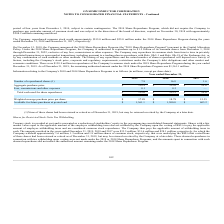According to On Semiconductor's financial document, When was "Capital Allocation Policy" announced? According to the financial document, December 1, 2014. The relevant text states: "period of four years from December 1, 2014, subject to certain contingencies. The 2014 Share Repurchase Program, which did not require the Com..." Also, How is "free cash flow" defined for the the purposes of the Capital Allocation Policy? Based on the financial document, the answer is net cash provided by operating activities less purchases of property, plant and equipment.. Also, What is the aggregate purchase price in 2019? According to the financial document, $138.9 (in millions). The relevant text states: "d other market and economic conditions. There were $138.9 million in repurchases of the Company's common stock under the 2018 Share Repurchase Program during..." Also, can you calculate: What is the change in Number of repurchased shares from December 31, 2018 to 2019? Based on the calculation: 7.8-16.8, the result is -9 (in millions). This is based on the information: "Number of repurchased shares (1) 7.8 16.8 1.6 Number of repurchased shares (1) 7.8 16.8 1.6..." The key data points involved are: 16.8, 7.8. Also, can you calculate: What is the change in Aggregate purchase price from year ended December 31, 2018 to 2019? Based on the calculation: 138.9-315.0, the result is -176.1 (in millions). This is based on the information: "other market and economic conditions. There were $138.9 million in repurchases of the Company's common stock under the 2018 Share Repurchase Program during any repurchased common stock worth approxima..." The key data points involved are: 138.9, 315.0. Also, can you calculate: What is the average Number of repurchased shares for December 31, 2018 to 2019? To answer this question, I need to perform calculations using the financial data. The calculation is: (7.8+16.8) / 2, which equals 12.3 (in millions). This is based on the information: "Number of repurchased shares (1) 7.8 16.8 1.6 Number of repurchased shares (1) 7.8 16.8 1.6..." The key data points involved are: 16.8, 7.8. 